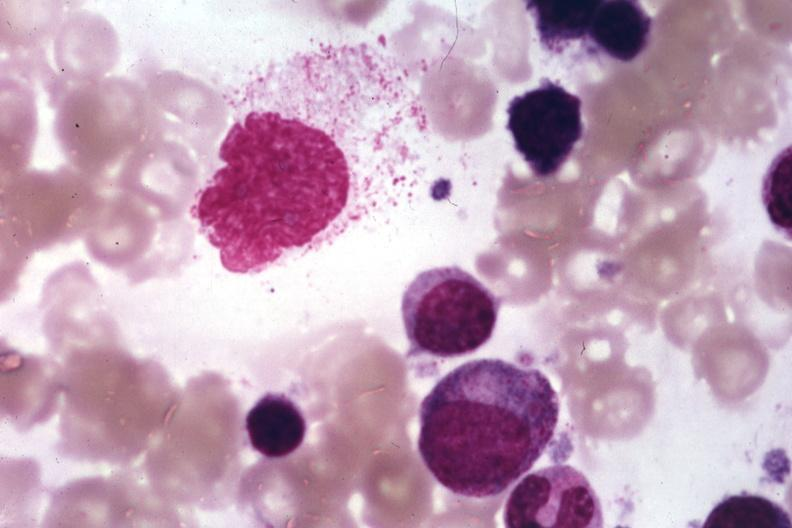does this image show wrights?
Answer the question using a single word or phrase. Yes 